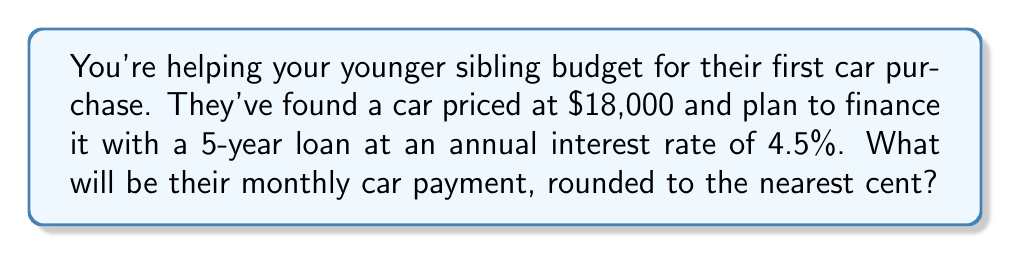Could you help me with this problem? Let's approach this step-by-step using the car loan payment formula:

$$P = \frac{r(PV)}{1-(1+r)^{-n}}$$

Where:
$P$ = Monthly payment
$r$ = Monthly interest rate
$PV$ = Present value (loan amount)
$n$ = Total number of months

1) First, let's organize our given information:
   $PV = $18,000
   Annual interest rate = 4.5% = 0.045
   Loan term = 5 years = 60 months

2) Calculate the monthly interest rate:
   $r = \frac{0.045}{12} = 0.00375$

3) Now, let's plug these values into our formula:

   $$P = \frac{0.00375($18,000)}{1-(1+0.00375)^{-60}}$$

4) Let's solve the denominator first:
   $(1+0.00375)^{-60} = 0.7987$
   $1 - 0.7987 = 0.2013$

5) Now our equation looks like:

   $$P = \frac{0.00375($18,000)}{0.2013} = \frac{67.5}{0.2013}$$

6) Solving this:
   $P = 335.32$

7) Rounding to the nearest cent:
   $P = $335.32$
Answer: $335.32 